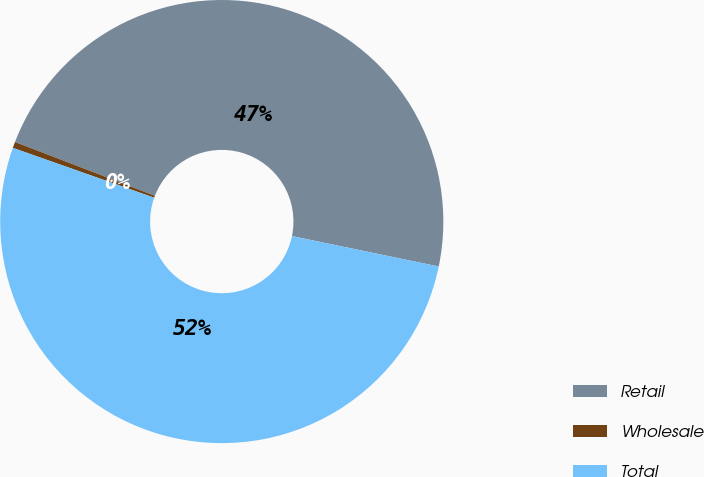Convert chart to OTSL. <chart><loc_0><loc_0><loc_500><loc_500><pie_chart><fcel>Retail<fcel>Wholesale<fcel>Total<nl><fcel>47.4%<fcel>0.45%<fcel>52.14%<nl></chart> 